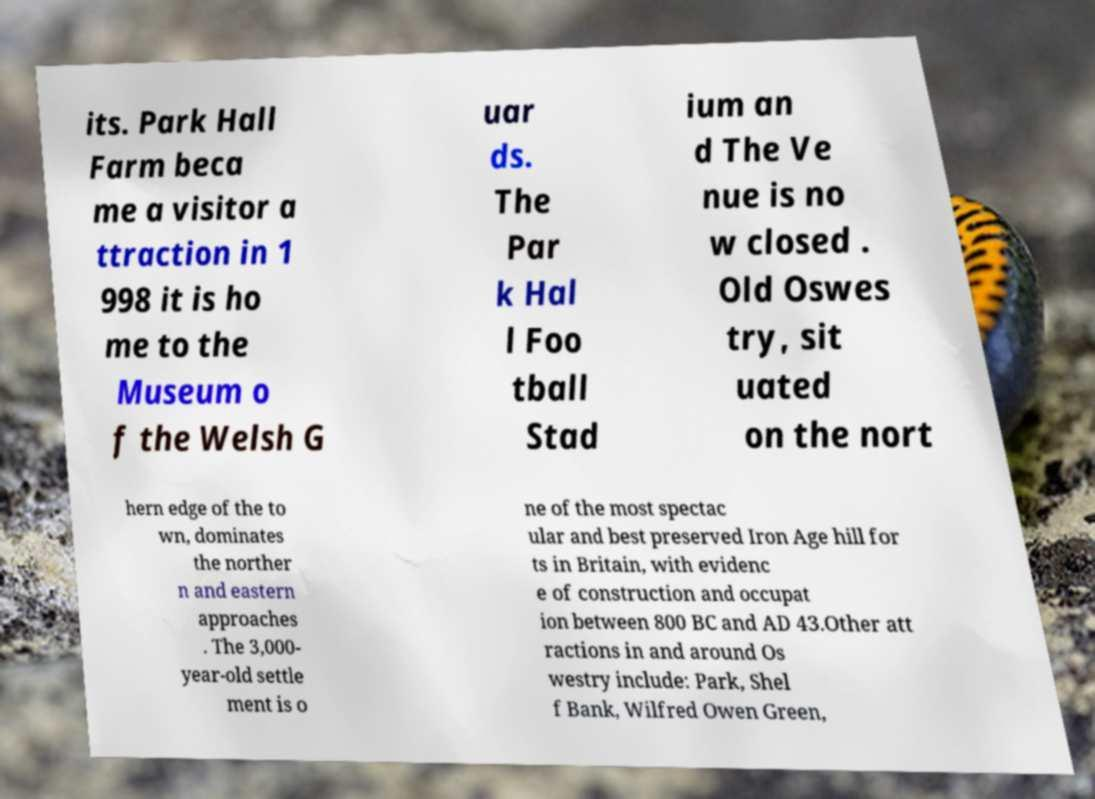Please identify and transcribe the text found in this image. its. Park Hall Farm beca me a visitor a ttraction in 1 998 it is ho me to the Museum o f the Welsh G uar ds. The Par k Hal l Foo tball Stad ium an d The Ve nue is no w closed . Old Oswes try, sit uated on the nort hern edge of the to wn, dominates the norther n and eastern approaches . The 3,000- year-old settle ment is o ne of the most spectac ular and best preserved Iron Age hill for ts in Britain, with evidenc e of construction and occupat ion between 800 BC and AD 43.Other att ractions in and around Os westry include: Park, Shel f Bank, Wilfred Owen Green, 